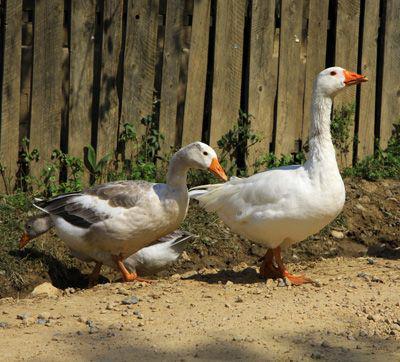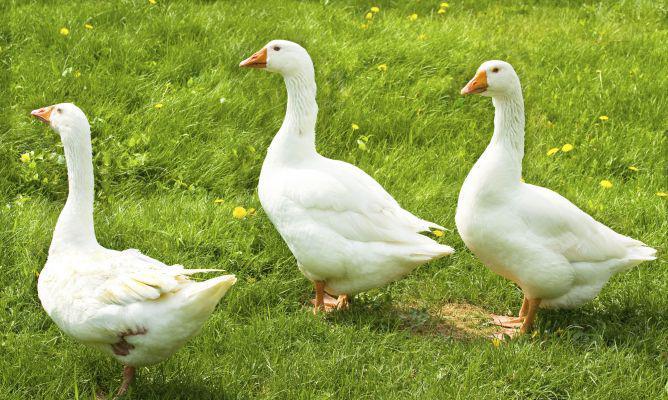The first image is the image on the left, the second image is the image on the right. Evaluate the accuracy of this statement regarding the images: "The right image contains exactly two ducks walking on grass.". Is it true? Answer yes or no. No. The first image is the image on the left, the second image is the image on the right. For the images displayed, is the sentence "One image contains exactly three solid-white ducks, and the other image contains at least one solid-white duck." factually correct? Answer yes or no. Yes. 